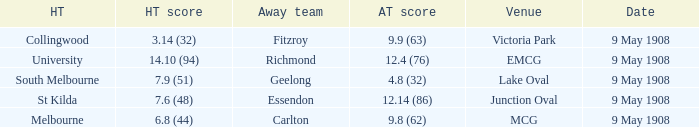Name the away team score for lake oval 4.8 (32). 